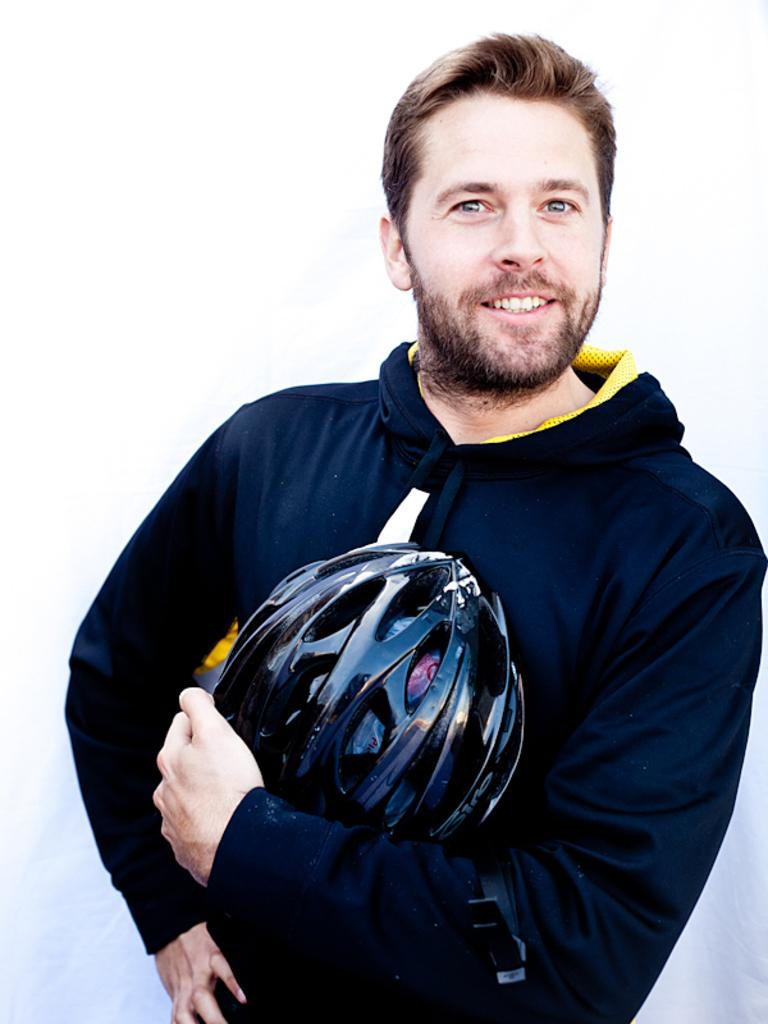What is present in the image? There is a person in the image. Can you describe what the person is wearing? The person is wearing a black hoodie. What object is the person holding in their hand? The person is holding a helmet in one of their hands. What type of box can be seen in the image? There is no box present in the image. Is there a tent visible in the image? There is no tent present in the image. 